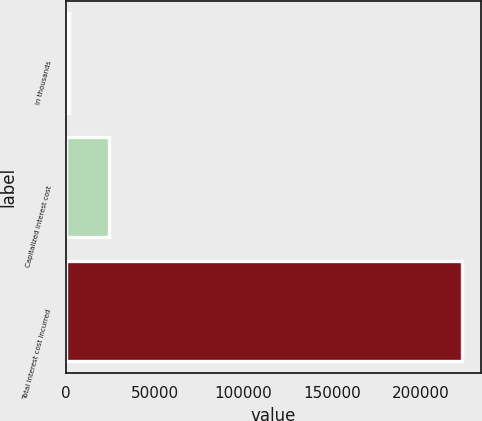Convert chart to OTSL. <chart><loc_0><loc_0><loc_500><loc_500><bar_chart><fcel>in thousands<fcel>Capitalized interest cost<fcel>Total interest cost incurred<nl><fcel>2011<fcel>24140.2<fcel>223303<nl></chart> 